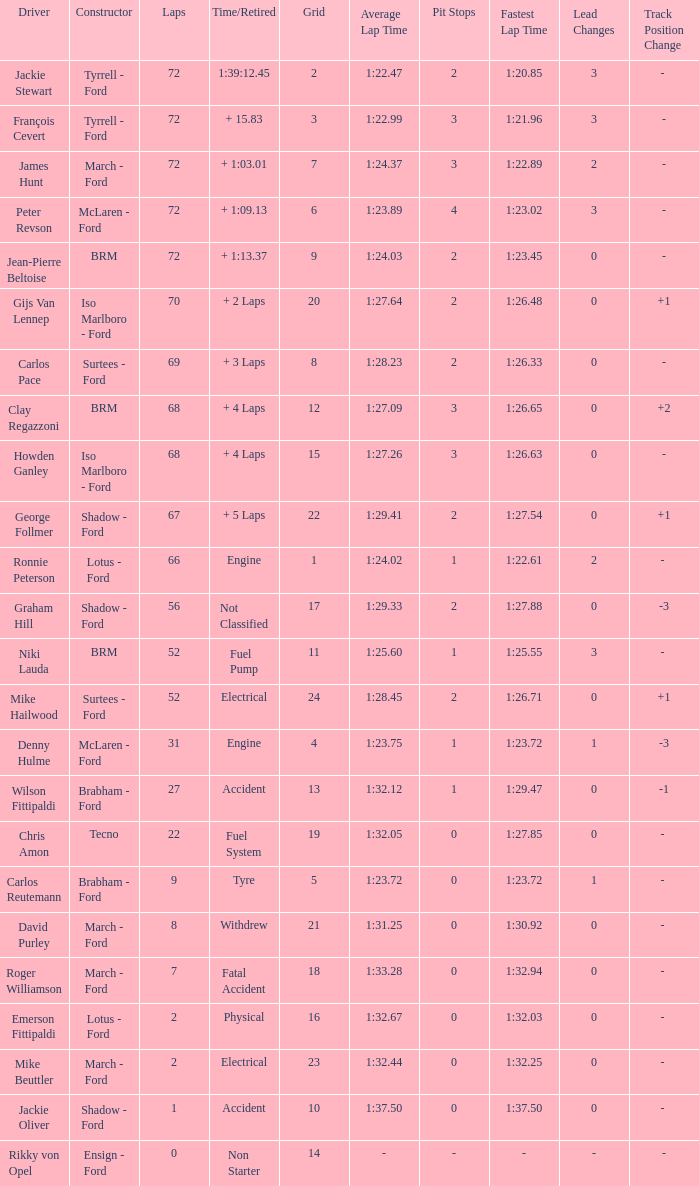What is the top grid that laps less than 66 and a retried engine? 4.0. 